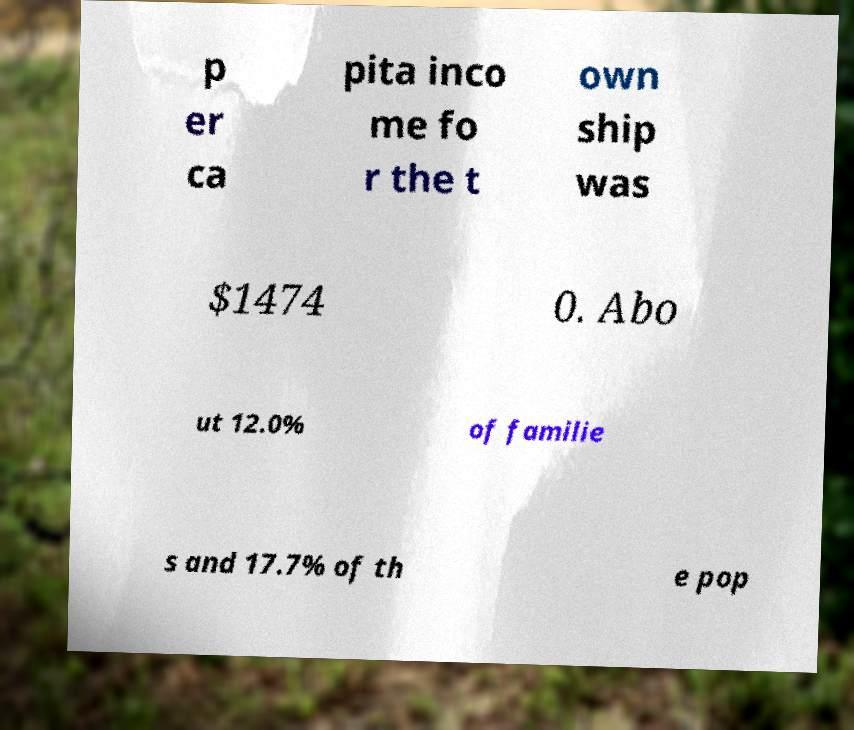What messages or text are displayed in this image? I need them in a readable, typed format. p er ca pita inco me fo r the t own ship was $1474 0. Abo ut 12.0% of familie s and 17.7% of th e pop 